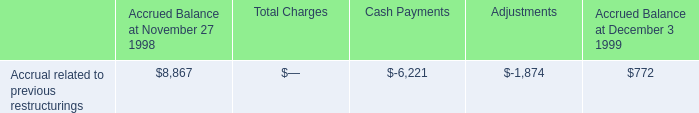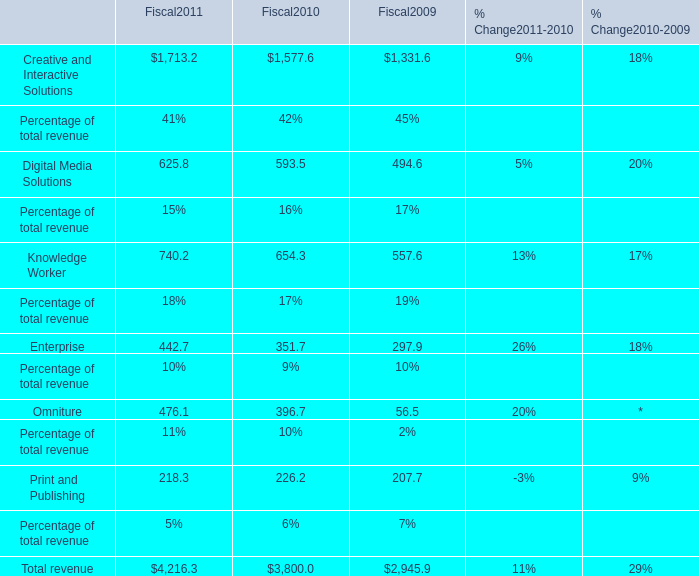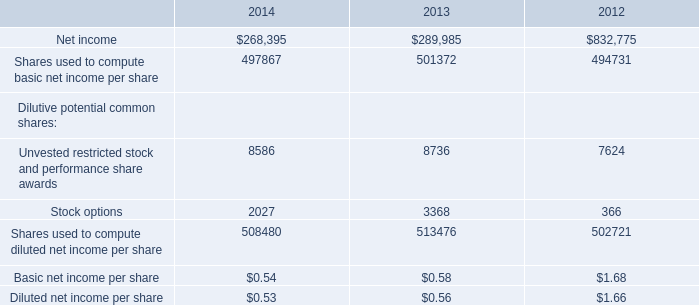what's the total amount of Net income of 2012, and Creative and Interactive Solutions of Fiscal2010 ? 
Computations: (832775.0 + 1577.6)
Answer: 834352.6. 